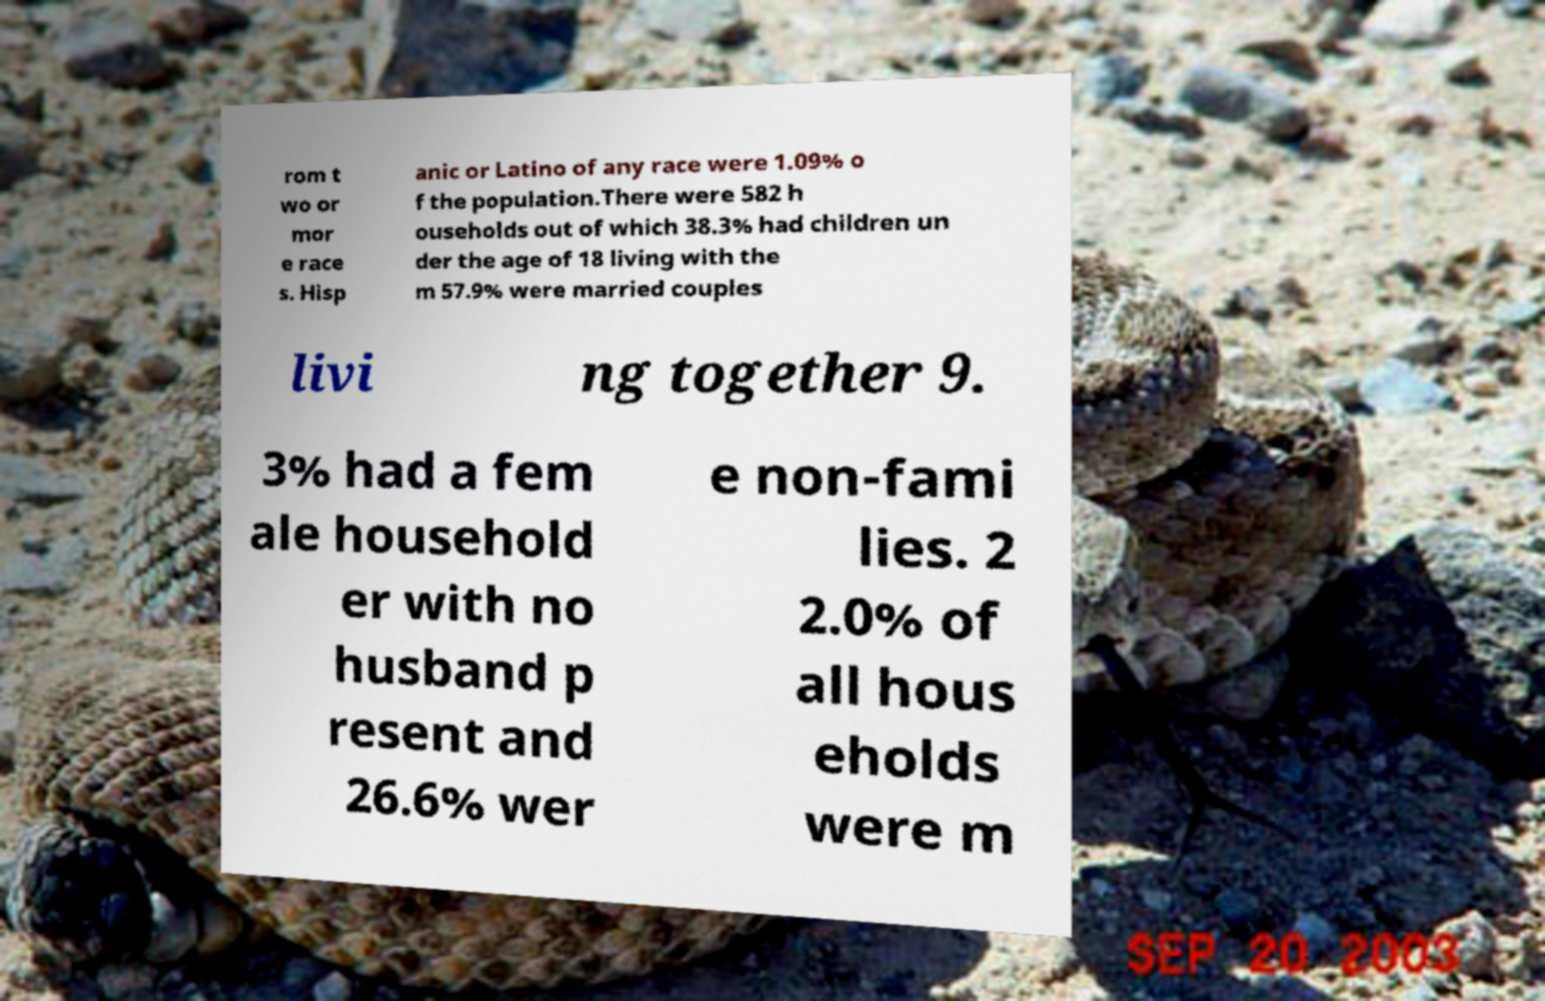There's text embedded in this image that I need extracted. Can you transcribe it verbatim? rom t wo or mor e race s. Hisp anic or Latino of any race were 1.09% o f the population.There were 582 h ouseholds out of which 38.3% had children un der the age of 18 living with the m 57.9% were married couples livi ng together 9. 3% had a fem ale household er with no husband p resent and 26.6% wer e non-fami lies. 2 2.0% of all hous eholds were m 